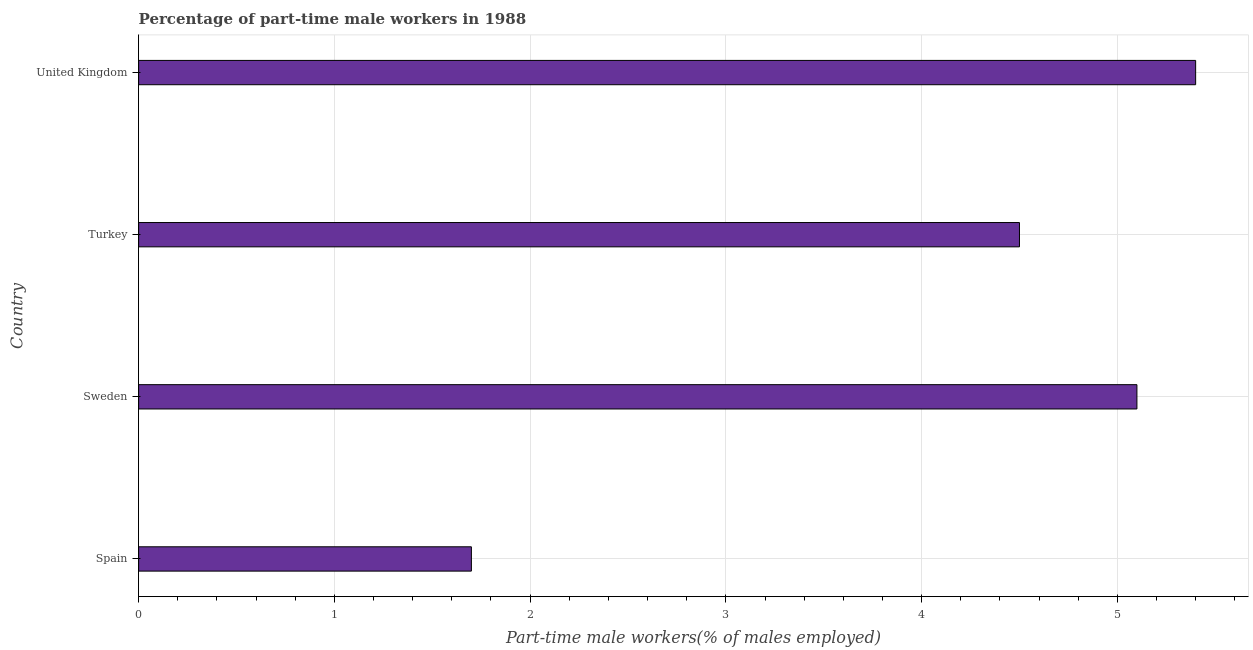Does the graph contain any zero values?
Your answer should be compact. No. What is the title of the graph?
Provide a short and direct response. Percentage of part-time male workers in 1988. What is the label or title of the X-axis?
Offer a terse response. Part-time male workers(% of males employed). What is the label or title of the Y-axis?
Offer a terse response. Country. What is the percentage of part-time male workers in United Kingdom?
Ensure brevity in your answer.  5.4. Across all countries, what is the maximum percentage of part-time male workers?
Make the answer very short. 5.4. Across all countries, what is the minimum percentage of part-time male workers?
Your response must be concise. 1.7. What is the sum of the percentage of part-time male workers?
Offer a terse response. 16.7. What is the average percentage of part-time male workers per country?
Keep it short and to the point. 4.17. What is the median percentage of part-time male workers?
Ensure brevity in your answer.  4.8. What is the ratio of the percentage of part-time male workers in Sweden to that in United Kingdom?
Ensure brevity in your answer.  0.94. Is the difference between the percentage of part-time male workers in Turkey and United Kingdom greater than the difference between any two countries?
Provide a succinct answer. No. What is the difference between the highest and the lowest percentage of part-time male workers?
Offer a terse response. 3.7. In how many countries, is the percentage of part-time male workers greater than the average percentage of part-time male workers taken over all countries?
Provide a short and direct response. 3. Are all the bars in the graph horizontal?
Your answer should be compact. Yes. How many countries are there in the graph?
Ensure brevity in your answer.  4. Are the values on the major ticks of X-axis written in scientific E-notation?
Your answer should be very brief. No. What is the Part-time male workers(% of males employed) of Spain?
Ensure brevity in your answer.  1.7. What is the Part-time male workers(% of males employed) of Sweden?
Your answer should be very brief. 5.1. What is the Part-time male workers(% of males employed) of Turkey?
Your response must be concise. 4.5. What is the Part-time male workers(% of males employed) in United Kingdom?
Provide a succinct answer. 5.4. What is the difference between the Part-time male workers(% of males employed) in Spain and United Kingdom?
Ensure brevity in your answer.  -3.7. What is the difference between the Part-time male workers(% of males employed) in Sweden and United Kingdom?
Your answer should be very brief. -0.3. What is the difference between the Part-time male workers(% of males employed) in Turkey and United Kingdom?
Offer a terse response. -0.9. What is the ratio of the Part-time male workers(% of males employed) in Spain to that in Sweden?
Your answer should be very brief. 0.33. What is the ratio of the Part-time male workers(% of males employed) in Spain to that in Turkey?
Offer a very short reply. 0.38. What is the ratio of the Part-time male workers(% of males employed) in Spain to that in United Kingdom?
Offer a very short reply. 0.32. What is the ratio of the Part-time male workers(% of males employed) in Sweden to that in Turkey?
Your answer should be very brief. 1.13. What is the ratio of the Part-time male workers(% of males employed) in Sweden to that in United Kingdom?
Ensure brevity in your answer.  0.94. What is the ratio of the Part-time male workers(% of males employed) in Turkey to that in United Kingdom?
Ensure brevity in your answer.  0.83. 